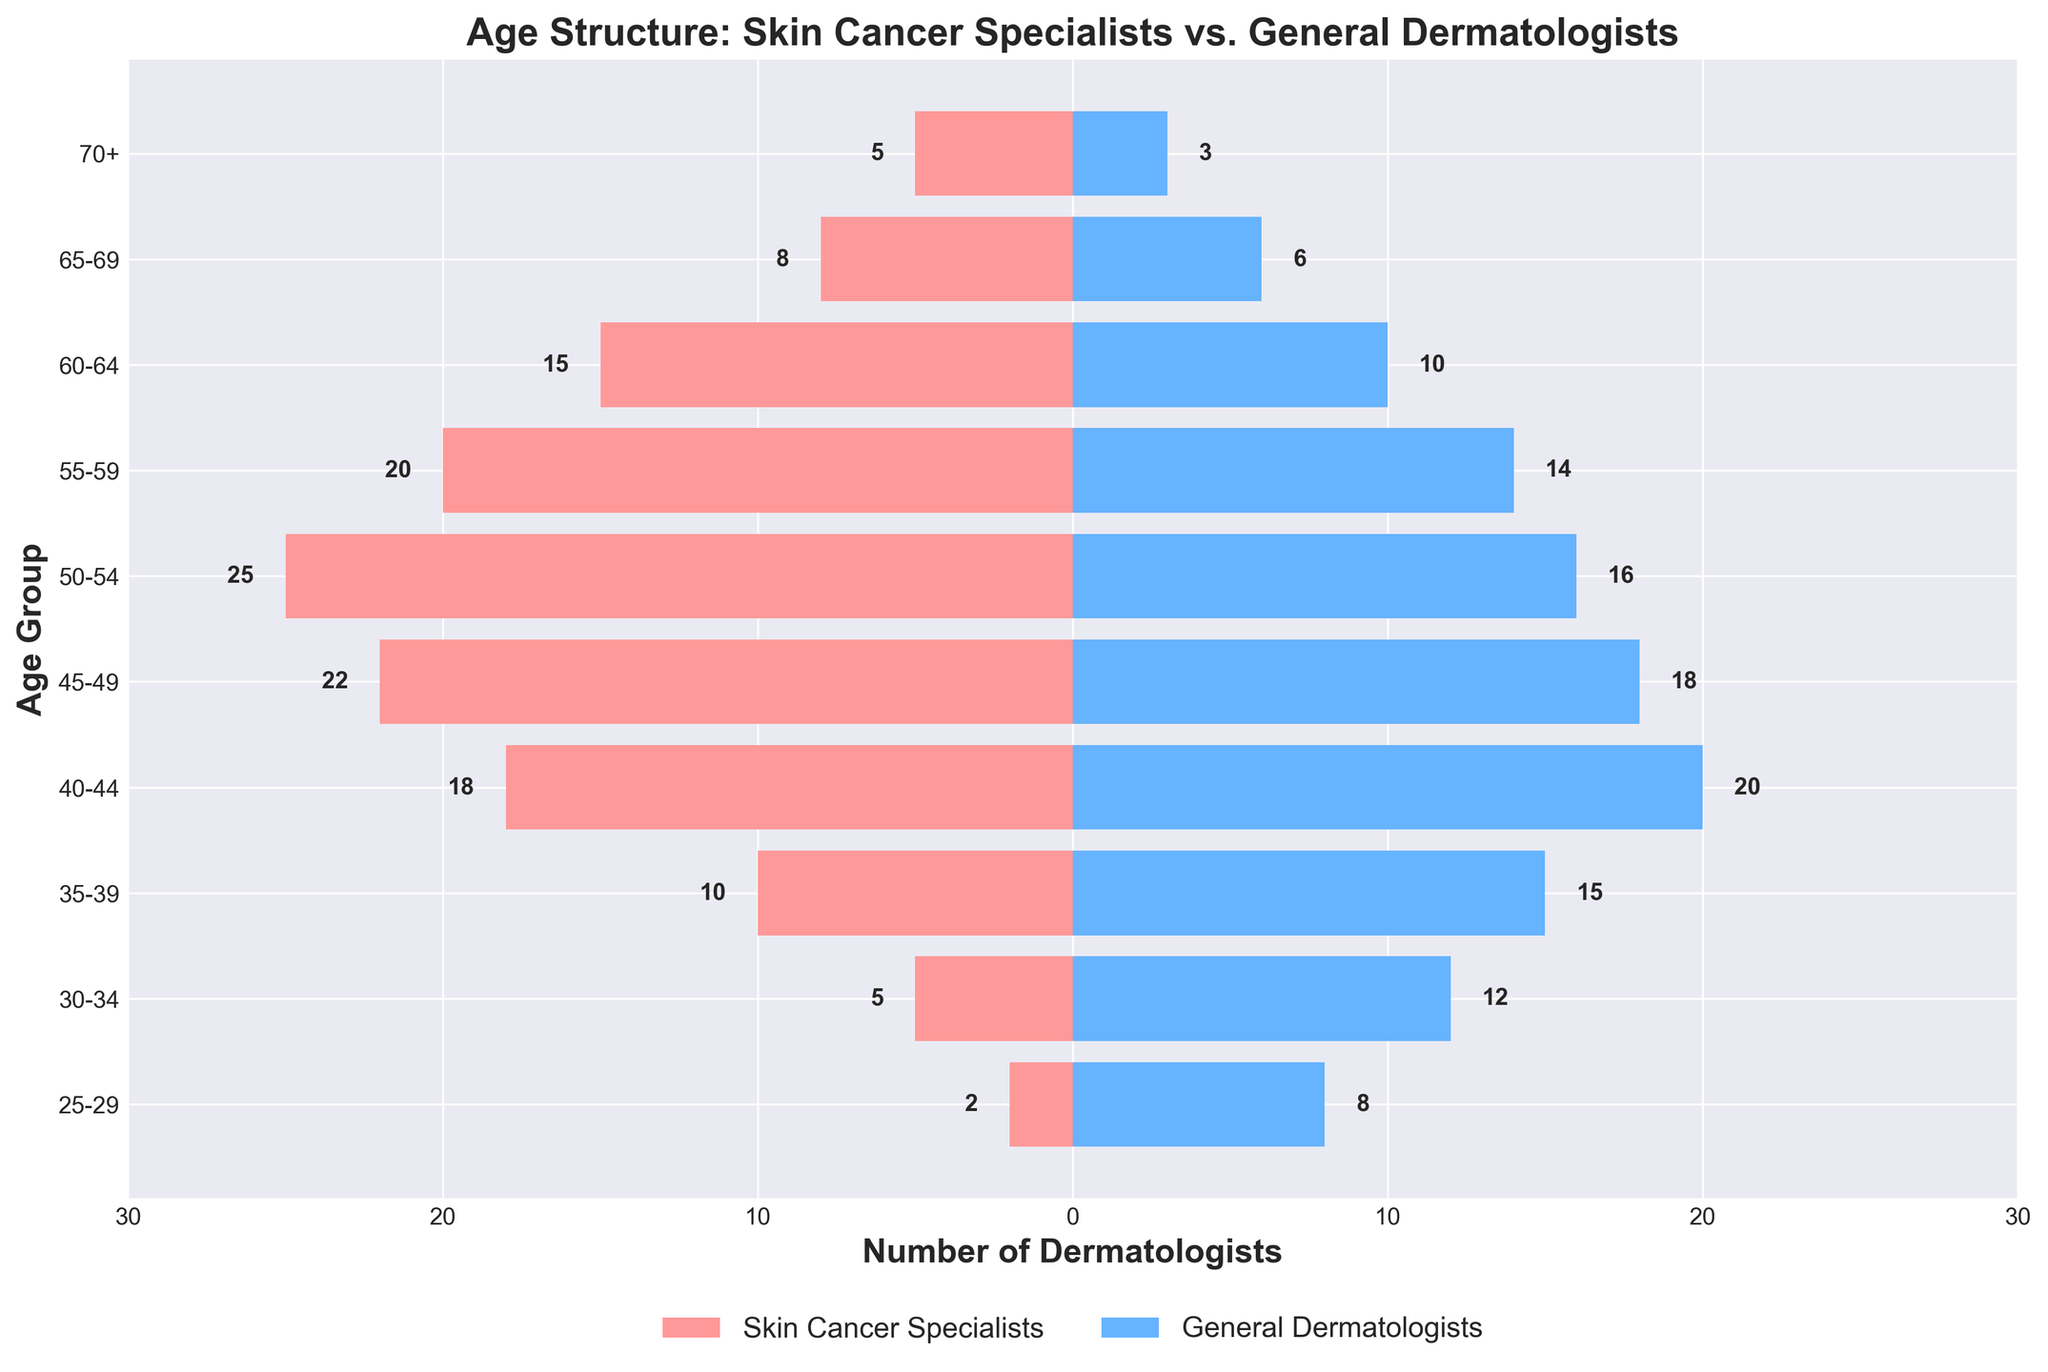What's the title of the figure? The title is located at the top of the figure in a larger, bold font. It provides a summary of what the figure represents.
Answer: Age Structure: Skin Cancer Specialists vs. General Dermatologists What age group has the highest number of skin cancer specialists? To determine the age group with the highest number of skin cancer specialists, look for the widest red bar on the left side of the plot.
Answer: 50-54 Which age group has more general dermatologists compared to skin cancer specialists? Compare the blue and red bars for each age group and identify the ones where the blue bar extends farther to the right compared to the red bar extending to the left.
Answer: 25-29, 30-34, 35-39, 40-44 In which age groups is the number of skin cancer specialists greater than the number of general dermatologists? Compare the lengths of the bars: the red bar extends further left of zero than the blue bar extends to the right for specific age groups.
Answer: 45-49, 50-54, 55-59, 60-64, 65-69, 70+ What is the total number of dermatologists aged 50-54? Add the number of skin cancer specialists and general dermatologists in the 50-54 age group.
Answer: 41 How many more skin cancer specialists are there than general dermatologists in the 65-69 age group? Subtract the number of general dermatologists from the number of skin cancer specialists in the 65-69 age group.
Answer: 2 Which side of the population pyramid represents the skin cancer specialists? Identify the color and positioning of the bars that represent skin cancer specialists.
Answer: Left (Red) Which age group has the lowest total number of dermatologists when combining both specializations? Sum the values for both skin cancer specialists and general dermatologists for each age group, and identify the smallest total.
Answer: 70+ What can you infer about the distribution of general dermatologists across age groups compared to skin cancer specialists? Observe the general trend for each group: where the blue bars peak and taper off compared to the red bars.
Answer: General dermatologists are more evenly distributed across younger age groups, while skin cancer specialists are more concentrated in the middle to older age groups 